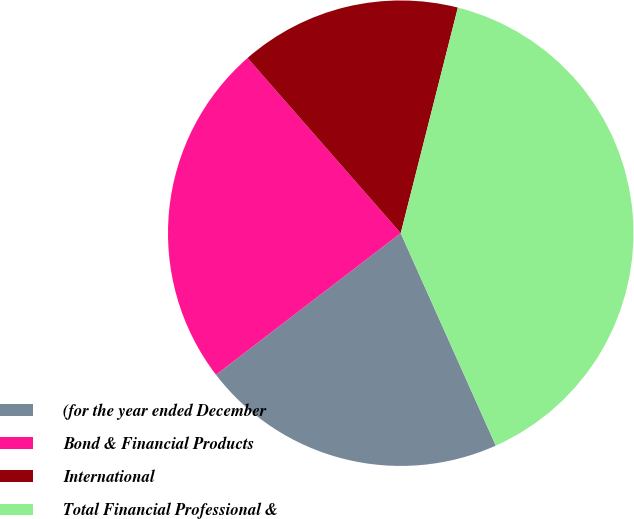Convert chart. <chart><loc_0><loc_0><loc_500><loc_500><pie_chart><fcel>(for the year ended December<fcel>Bond & Financial Products<fcel>International<fcel>Total Financial Professional &<nl><fcel>21.29%<fcel>23.97%<fcel>15.38%<fcel>39.35%<nl></chart> 